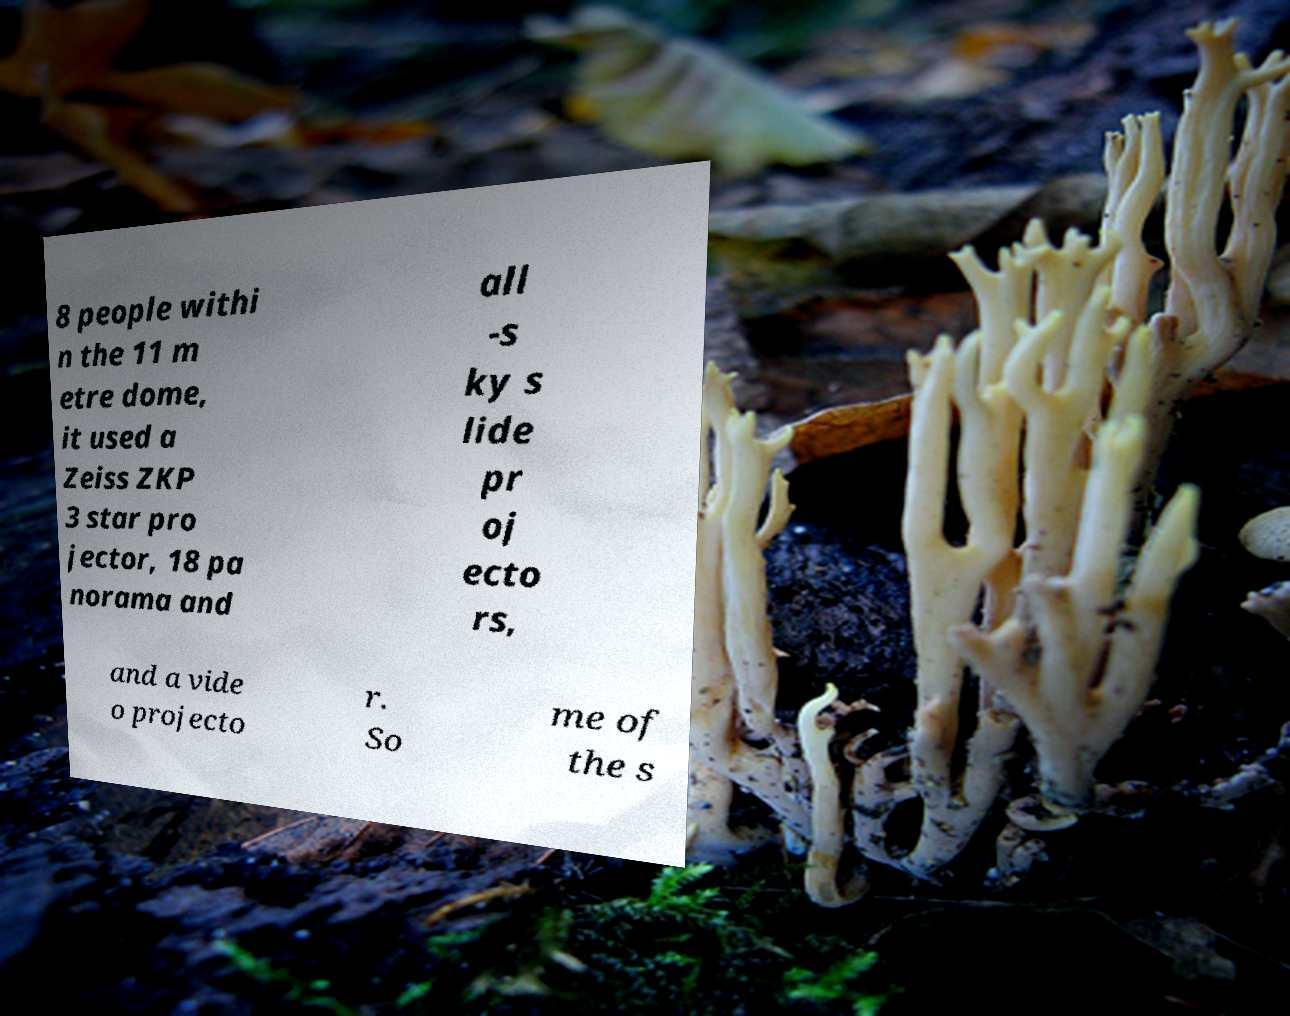Can you read and provide the text displayed in the image?This photo seems to have some interesting text. Can you extract and type it out for me? 8 people withi n the 11 m etre dome, it used a Zeiss ZKP 3 star pro jector, 18 pa norama and all -s ky s lide pr oj ecto rs, and a vide o projecto r. So me of the s 